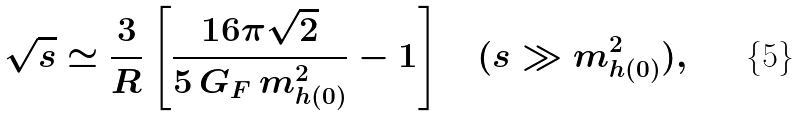<formula> <loc_0><loc_0><loc_500><loc_500>\sqrt { s } \simeq \frac { 3 } { R } \left [ \frac { 1 6 \pi \sqrt { 2 } } { 5 \, G _ { F } \, m ^ { 2 } _ { h ( 0 ) } } - 1 \right ] \quad ( s \gg m ^ { 2 } _ { h ( 0 ) } ) ,</formula> 